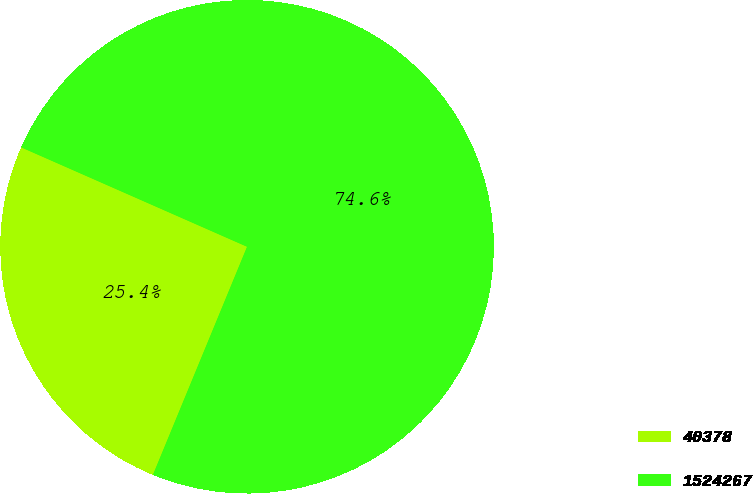<chart> <loc_0><loc_0><loc_500><loc_500><pie_chart><fcel>40378<fcel>1524267<nl><fcel>25.37%<fcel>74.63%<nl></chart> 